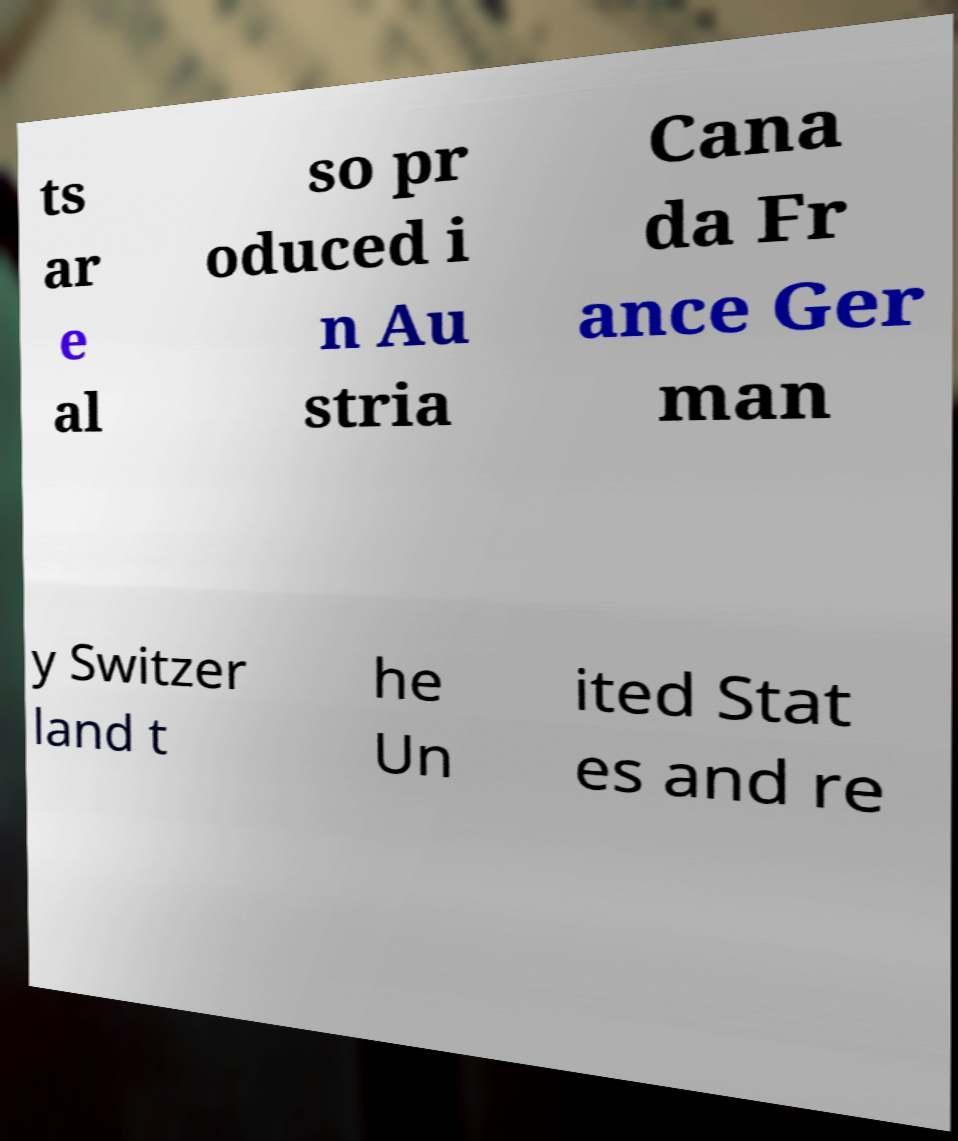I need the written content from this picture converted into text. Can you do that? ts ar e al so pr oduced i n Au stria Cana da Fr ance Ger man y Switzer land t he Un ited Stat es and re 